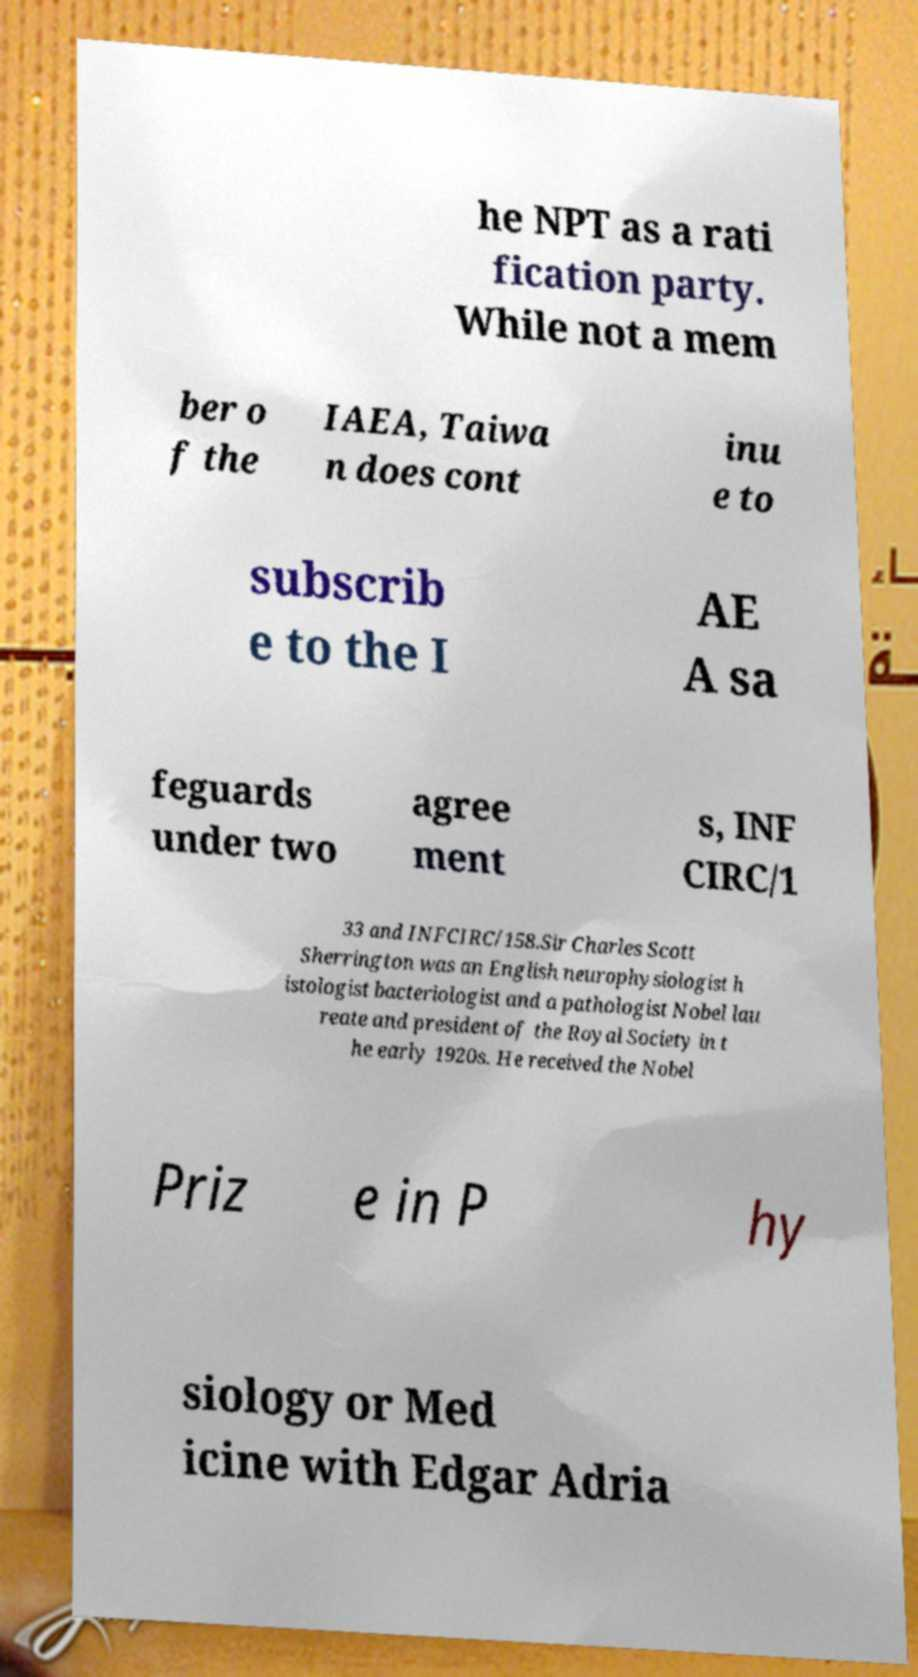For documentation purposes, I need the text within this image transcribed. Could you provide that? he NPT as a rati fication party. While not a mem ber o f the IAEA, Taiwa n does cont inu e to subscrib e to the I AE A sa feguards under two agree ment s, INF CIRC/1 33 and INFCIRC/158.Sir Charles Scott Sherrington was an English neurophysiologist h istologist bacteriologist and a pathologist Nobel lau reate and president of the Royal Society in t he early 1920s. He received the Nobel Priz e in P hy siology or Med icine with Edgar Adria 